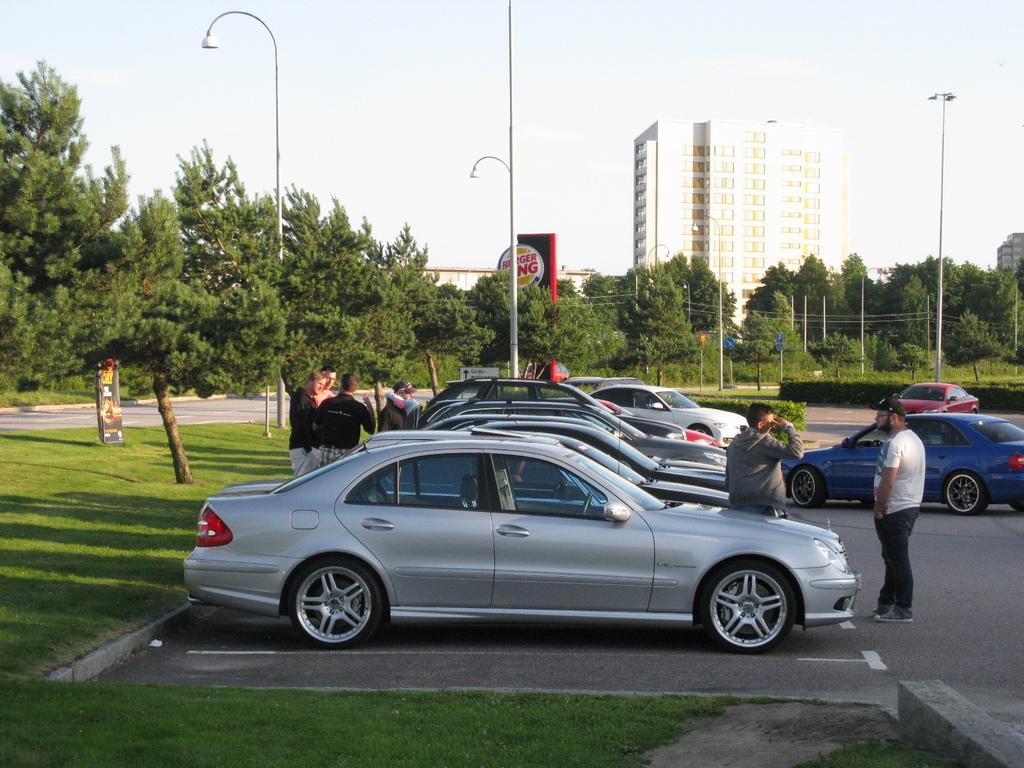How would you summarize this image in a sentence or two? In this image there are cars which are parked on the road one beside the other. There are few people who are standing in between the cars. In the background there is a tall building. Behind the car there is grass on which there are poles. At the top there is sky. In the background there are so many trees. 